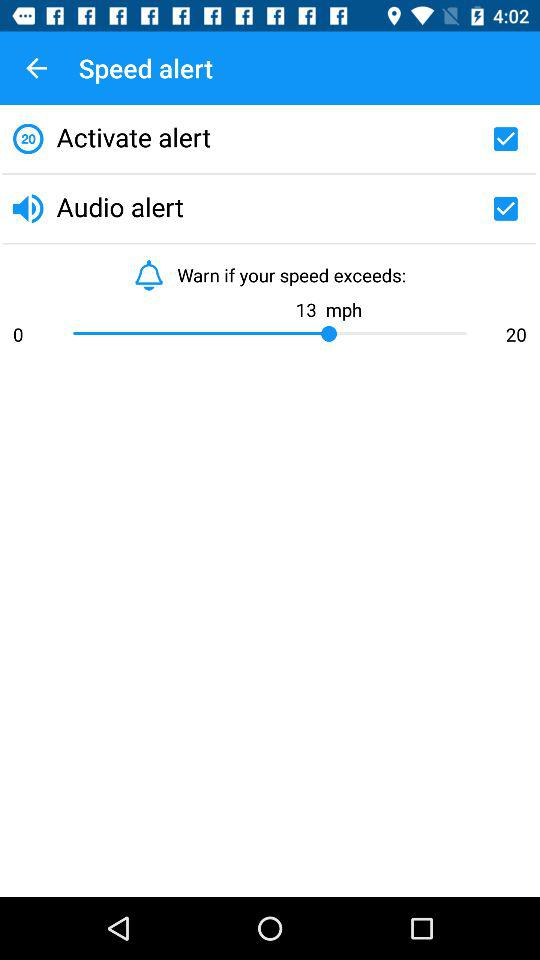How much is the speed limit, exceeding which a warning will be received? A warning will be received after exceeding the speed limit of 13 mph. 